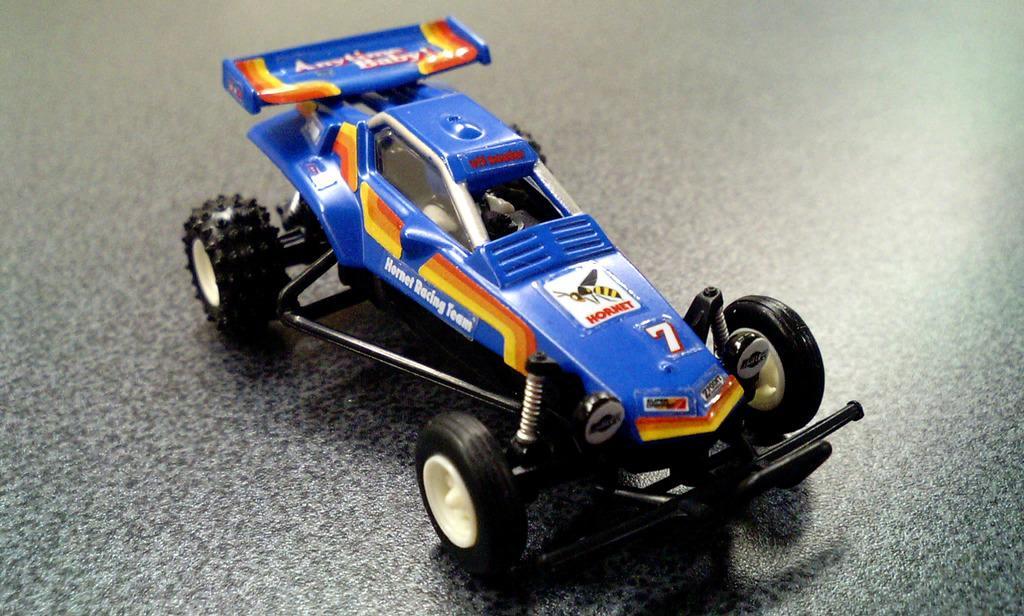Could you give a brief overview of what you see in this image? This is a zoomed in picture. In the center there is a blue color Go-kart toy placed on the ground. 